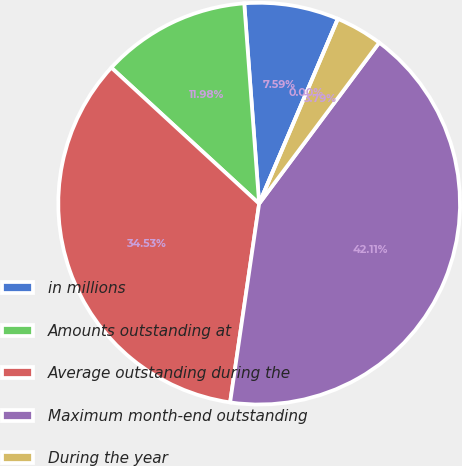<chart> <loc_0><loc_0><loc_500><loc_500><pie_chart><fcel>in millions<fcel>Amounts outstanding at<fcel>Average outstanding during the<fcel>Maximum month-end outstanding<fcel>During the year<fcel>At year-end<nl><fcel>7.59%<fcel>11.98%<fcel>34.53%<fcel>42.11%<fcel>3.79%<fcel>0.0%<nl></chart> 